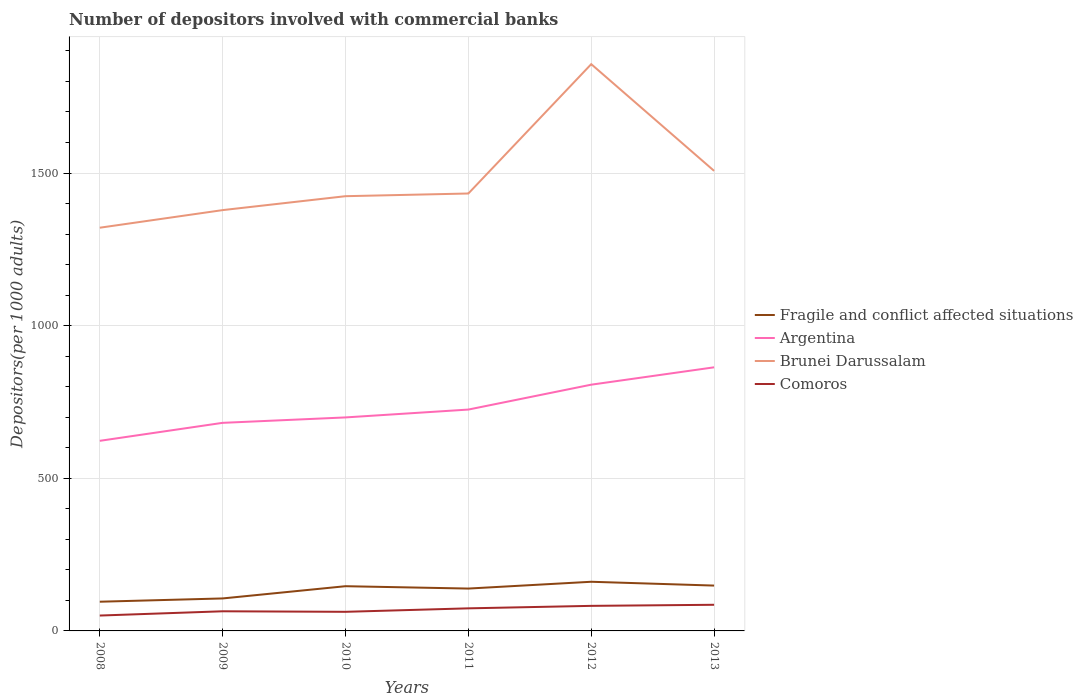Does the line corresponding to Argentina intersect with the line corresponding to Comoros?
Offer a terse response. No. Is the number of lines equal to the number of legend labels?
Your answer should be very brief. Yes. Across all years, what is the maximum number of depositors involved with commercial banks in Brunei Darussalam?
Keep it short and to the point. 1320.81. In which year was the number of depositors involved with commercial banks in Argentina maximum?
Keep it short and to the point. 2008. What is the total number of depositors involved with commercial banks in Brunei Darussalam in the graph?
Make the answer very short. -128.58. What is the difference between the highest and the second highest number of depositors involved with commercial banks in Brunei Darussalam?
Provide a short and direct response. 535.79. Is the number of depositors involved with commercial banks in Fragile and conflict affected situations strictly greater than the number of depositors involved with commercial banks in Brunei Darussalam over the years?
Give a very brief answer. Yes. How many lines are there?
Make the answer very short. 4. Are the values on the major ticks of Y-axis written in scientific E-notation?
Your answer should be very brief. No. Does the graph contain any zero values?
Offer a terse response. No. How are the legend labels stacked?
Provide a short and direct response. Vertical. What is the title of the graph?
Your answer should be compact. Number of depositors involved with commercial banks. Does "Namibia" appear as one of the legend labels in the graph?
Your response must be concise. No. What is the label or title of the Y-axis?
Make the answer very short. Depositors(per 1000 adults). What is the Depositors(per 1000 adults) in Fragile and conflict affected situations in 2008?
Provide a succinct answer. 95.65. What is the Depositors(per 1000 adults) in Argentina in 2008?
Ensure brevity in your answer.  622.73. What is the Depositors(per 1000 adults) in Brunei Darussalam in 2008?
Offer a terse response. 1320.81. What is the Depositors(per 1000 adults) in Comoros in 2008?
Your answer should be compact. 50.36. What is the Depositors(per 1000 adults) in Fragile and conflict affected situations in 2009?
Ensure brevity in your answer.  106.41. What is the Depositors(per 1000 adults) of Argentina in 2009?
Give a very brief answer. 681.62. What is the Depositors(per 1000 adults) in Brunei Darussalam in 2009?
Make the answer very short. 1378.46. What is the Depositors(per 1000 adults) in Comoros in 2009?
Keep it short and to the point. 64.34. What is the Depositors(per 1000 adults) in Fragile and conflict affected situations in 2010?
Offer a very short reply. 146.5. What is the Depositors(per 1000 adults) in Argentina in 2010?
Provide a short and direct response. 699.37. What is the Depositors(per 1000 adults) in Brunei Darussalam in 2010?
Your answer should be very brief. 1424.06. What is the Depositors(per 1000 adults) of Comoros in 2010?
Offer a very short reply. 62.59. What is the Depositors(per 1000 adults) in Fragile and conflict affected situations in 2011?
Provide a short and direct response. 138.74. What is the Depositors(per 1000 adults) of Argentina in 2011?
Make the answer very short. 725.1. What is the Depositors(per 1000 adults) in Brunei Darussalam in 2011?
Your response must be concise. 1432.88. What is the Depositors(per 1000 adults) of Comoros in 2011?
Provide a succinct answer. 73.96. What is the Depositors(per 1000 adults) of Fragile and conflict affected situations in 2012?
Keep it short and to the point. 161.02. What is the Depositors(per 1000 adults) of Argentina in 2012?
Make the answer very short. 806.63. What is the Depositors(per 1000 adults) in Brunei Darussalam in 2012?
Keep it short and to the point. 1856.6. What is the Depositors(per 1000 adults) in Comoros in 2012?
Give a very brief answer. 82.09. What is the Depositors(per 1000 adults) of Fragile and conflict affected situations in 2013?
Ensure brevity in your answer.  148.53. What is the Depositors(per 1000 adults) in Argentina in 2013?
Ensure brevity in your answer.  863.51. What is the Depositors(per 1000 adults) of Brunei Darussalam in 2013?
Provide a short and direct response. 1507.03. What is the Depositors(per 1000 adults) in Comoros in 2013?
Give a very brief answer. 85.63. Across all years, what is the maximum Depositors(per 1000 adults) of Fragile and conflict affected situations?
Your answer should be compact. 161.02. Across all years, what is the maximum Depositors(per 1000 adults) in Argentina?
Ensure brevity in your answer.  863.51. Across all years, what is the maximum Depositors(per 1000 adults) in Brunei Darussalam?
Your answer should be very brief. 1856.6. Across all years, what is the maximum Depositors(per 1000 adults) in Comoros?
Provide a succinct answer. 85.63. Across all years, what is the minimum Depositors(per 1000 adults) in Fragile and conflict affected situations?
Offer a terse response. 95.65. Across all years, what is the minimum Depositors(per 1000 adults) in Argentina?
Keep it short and to the point. 622.73. Across all years, what is the minimum Depositors(per 1000 adults) of Brunei Darussalam?
Offer a terse response. 1320.81. Across all years, what is the minimum Depositors(per 1000 adults) of Comoros?
Keep it short and to the point. 50.36. What is the total Depositors(per 1000 adults) in Fragile and conflict affected situations in the graph?
Make the answer very short. 796.85. What is the total Depositors(per 1000 adults) of Argentina in the graph?
Ensure brevity in your answer.  4398.97. What is the total Depositors(per 1000 adults) in Brunei Darussalam in the graph?
Provide a succinct answer. 8919.83. What is the total Depositors(per 1000 adults) of Comoros in the graph?
Provide a short and direct response. 418.97. What is the difference between the Depositors(per 1000 adults) of Fragile and conflict affected situations in 2008 and that in 2009?
Provide a short and direct response. -10.75. What is the difference between the Depositors(per 1000 adults) of Argentina in 2008 and that in 2009?
Provide a short and direct response. -58.89. What is the difference between the Depositors(per 1000 adults) of Brunei Darussalam in 2008 and that in 2009?
Provide a short and direct response. -57.65. What is the difference between the Depositors(per 1000 adults) of Comoros in 2008 and that in 2009?
Provide a short and direct response. -13.99. What is the difference between the Depositors(per 1000 adults) of Fragile and conflict affected situations in 2008 and that in 2010?
Make the answer very short. -50.84. What is the difference between the Depositors(per 1000 adults) in Argentina in 2008 and that in 2010?
Your answer should be very brief. -76.64. What is the difference between the Depositors(per 1000 adults) in Brunei Darussalam in 2008 and that in 2010?
Keep it short and to the point. -103.26. What is the difference between the Depositors(per 1000 adults) of Comoros in 2008 and that in 2010?
Your response must be concise. -12.23. What is the difference between the Depositors(per 1000 adults) of Fragile and conflict affected situations in 2008 and that in 2011?
Provide a short and direct response. -43.09. What is the difference between the Depositors(per 1000 adults) of Argentina in 2008 and that in 2011?
Offer a very short reply. -102.37. What is the difference between the Depositors(per 1000 adults) of Brunei Darussalam in 2008 and that in 2011?
Your answer should be very brief. -112.07. What is the difference between the Depositors(per 1000 adults) in Comoros in 2008 and that in 2011?
Offer a terse response. -23.61. What is the difference between the Depositors(per 1000 adults) in Fragile and conflict affected situations in 2008 and that in 2012?
Make the answer very short. -65.37. What is the difference between the Depositors(per 1000 adults) in Argentina in 2008 and that in 2012?
Your answer should be very brief. -183.9. What is the difference between the Depositors(per 1000 adults) in Brunei Darussalam in 2008 and that in 2012?
Your answer should be compact. -535.79. What is the difference between the Depositors(per 1000 adults) of Comoros in 2008 and that in 2012?
Keep it short and to the point. -31.74. What is the difference between the Depositors(per 1000 adults) in Fragile and conflict affected situations in 2008 and that in 2013?
Make the answer very short. -52.88. What is the difference between the Depositors(per 1000 adults) of Argentina in 2008 and that in 2013?
Ensure brevity in your answer.  -240.78. What is the difference between the Depositors(per 1000 adults) in Brunei Darussalam in 2008 and that in 2013?
Give a very brief answer. -186.23. What is the difference between the Depositors(per 1000 adults) in Comoros in 2008 and that in 2013?
Offer a very short reply. -35.27. What is the difference between the Depositors(per 1000 adults) of Fragile and conflict affected situations in 2009 and that in 2010?
Offer a very short reply. -40.09. What is the difference between the Depositors(per 1000 adults) in Argentina in 2009 and that in 2010?
Your response must be concise. -17.75. What is the difference between the Depositors(per 1000 adults) of Brunei Darussalam in 2009 and that in 2010?
Offer a terse response. -45.61. What is the difference between the Depositors(per 1000 adults) of Comoros in 2009 and that in 2010?
Make the answer very short. 1.75. What is the difference between the Depositors(per 1000 adults) of Fragile and conflict affected situations in 2009 and that in 2011?
Make the answer very short. -32.34. What is the difference between the Depositors(per 1000 adults) of Argentina in 2009 and that in 2011?
Give a very brief answer. -43.48. What is the difference between the Depositors(per 1000 adults) of Brunei Darussalam in 2009 and that in 2011?
Your answer should be compact. -54.42. What is the difference between the Depositors(per 1000 adults) of Comoros in 2009 and that in 2011?
Your response must be concise. -9.62. What is the difference between the Depositors(per 1000 adults) in Fragile and conflict affected situations in 2009 and that in 2012?
Offer a terse response. -54.61. What is the difference between the Depositors(per 1000 adults) of Argentina in 2009 and that in 2012?
Provide a succinct answer. -125.01. What is the difference between the Depositors(per 1000 adults) in Brunei Darussalam in 2009 and that in 2012?
Your answer should be compact. -478.14. What is the difference between the Depositors(per 1000 adults) of Comoros in 2009 and that in 2012?
Give a very brief answer. -17.75. What is the difference between the Depositors(per 1000 adults) of Fragile and conflict affected situations in 2009 and that in 2013?
Make the answer very short. -42.13. What is the difference between the Depositors(per 1000 adults) in Argentina in 2009 and that in 2013?
Ensure brevity in your answer.  -181.89. What is the difference between the Depositors(per 1000 adults) in Brunei Darussalam in 2009 and that in 2013?
Your answer should be compact. -128.58. What is the difference between the Depositors(per 1000 adults) of Comoros in 2009 and that in 2013?
Ensure brevity in your answer.  -21.29. What is the difference between the Depositors(per 1000 adults) in Fragile and conflict affected situations in 2010 and that in 2011?
Provide a short and direct response. 7.75. What is the difference between the Depositors(per 1000 adults) of Argentina in 2010 and that in 2011?
Provide a succinct answer. -25.73. What is the difference between the Depositors(per 1000 adults) in Brunei Darussalam in 2010 and that in 2011?
Your answer should be compact. -8.82. What is the difference between the Depositors(per 1000 adults) in Comoros in 2010 and that in 2011?
Your answer should be compact. -11.38. What is the difference between the Depositors(per 1000 adults) of Fragile and conflict affected situations in 2010 and that in 2012?
Provide a succinct answer. -14.52. What is the difference between the Depositors(per 1000 adults) in Argentina in 2010 and that in 2012?
Offer a terse response. -107.26. What is the difference between the Depositors(per 1000 adults) in Brunei Darussalam in 2010 and that in 2012?
Provide a succinct answer. -432.53. What is the difference between the Depositors(per 1000 adults) in Comoros in 2010 and that in 2012?
Ensure brevity in your answer.  -19.5. What is the difference between the Depositors(per 1000 adults) in Fragile and conflict affected situations in 2010 and that in 2013?
Keep it short and to the point. -2.04. What is the difference between the Depositors(per 1000 adults) in Argentina in 2010 and that in 2013?
Make the answer very short. -164.14. What is the difference between the Depositors(per 1000 adults) of Brunei Darussalam in 2010 and that in 2013?
Offer a terse response. -82.97. What is the difference between the Depositors(per 1000 adults) in Comoros in 2010 and that in 2013?
Provide a succinct answer. -23.04. What is the difference between the Depositors(per 1000 adults) of Fragile and conflict affected situations in 2011 and that in 2012?
Make the answer very short. -22.28. What is the difference between the Depositors(per 1000 adults) in Argentina in 2011 and that in 2012?
Your answer should be very brief. -81.53. What is the difference between the Depositors(per 1000 adults) in Brunei Darussalam in 2011 and that in 2012?
Your answer should be compact. -423.72. What is the difference between the Depositors(per 1000 adults) of Comoros in 2011 and that in 2012?
Offer a very short reply. -8.13. What is the difference between the Depositors(per 1000 adults) in Fragile and conflict affected situations in 2011 and that in 2013?
Your answer should be very brief. -9.79. What is the difference between the Depositors(per 1000 adults) in Argentina in 2011 and that in 2013?
Provide a short and direct response. -138.41. What is the difference between the Depositors(per 1000 adults) in Brunei Darussalam in 2011 and that in 2013?
Ensure brevity in your answer.  -74.15. What is the difference between the Depositors(per 1000 adults) of Comoros in 2011 and that in 2013?
Ensure brevity in your answer.  -11.66. What is the difference between the Depositors(per 1000 adults) in Fragile and conflict affected situations in 2012 and that in 2013?
Offer a terse response. 12.49. What is the difference between the Depositors(per 1000 adults) in Argentina in 2012 and that in 2013?
Your response must be concise. -56.88. What is the difference between the Depositors(per 1000 adults) of Brunei Darussalam in 2012 and that in 2013?
Offer a terse response. 349.56. What is the difference between the Depositors(per 1000 adults) of Comoros in 2012 and that in 2013?
Keep it short and to the point. -3.54. What is the difference between the Depositors(per 1000 adults) in Fragile and conflict affected situations in 2008 and the Depositors(per 1000 adults) in Argentina in 2009?
Offer a terse response. -585.97. What is the difference between the Depositors(per 1000 adults) of Fragile and conflict affected situations in 2008 and the Depositors(per 1000 adults) of Brunei Darussalam in 2009?
Provide a short and direct response. -1282.8. What is the difference between the Depositors(per 1000 adults) in Fragile and conflict affected situations in 2008 and the Depositors(per 1000 adults) in Comoros in 2009?
Your answer should be very brief. 31.31. What is the difference between the Depositors(per 1000 adults) in Argentina in 2008 and the Depositors(per 1000 adults) in Brunei Darussalam in 2009?
Provide a succinct answer. -755.72. What is the difference between the Depositors(per 1000 adults) of Argentina in 2008 and the Depositors(per 1000 adults) of Comoros in 2009?
Provide a short and direct response. 558.39. What is the difference between the Depositors(per 1000 adults) in Brunei Darussalam in 2008 and the Depositors(per 1000 adults) in Comoros in 2009?
Give a very brief answer. 1256.46. What is the difference between the Depositors(per 1000 adults) in Fragile and conflict affected situations in 2008 and the Depositors(per 1000 adults) in Argentina in 2010?
Your response must be concise. -603.72. What is the difference between the Depositors(per 1000 adults) of Fragile and conflict affected situations in 2008 and the Depositors(per 1000 adults) of Brunei Darussalam in 2010?
Your response must be concise. -1328.41. What is the difference between the Depositors(per 1000 adults) of Fragile and conflict affected situations in 2008 and the Depositors(per 1000 adults) of Comoros in 2010?
Your answer should be compact. 33.06. What is the difference between the Depositors(per 1000 adults) in Argentina in 2008 and the Depositors(per 1000 adults) in Brunei Darussalam in 2010?
Your answer should be compact. -801.33. What is the difference between the Depositors(per 1000 adults) of Argentina in 2008 and the Depositors(per 1000 adults) of Comoros in 2010?
Your answer should be very brief. 560.14. What is the difference between the Depositors(per 1000 adults) of Brunei Darussalam in 2008 and the Depositors(per 1000 adults) of Comoros in 2010?
Make the answer very short. 1258.22. What is the difference between the Depositors(per 1000 adults) in Fragile and conflict affected situations in 2008 and the Depositors(per 1000 adults) in Argentina in 2011?
Make the answer very short. -629.45. What is the difference between the Depositors(per 1000 adults) in Fragile and conflict affected situations in 2008 and the Depositors(per 1000 adults) in Brunei Darussalam in 2011?
Provide a succinct answer. -1337.23. What is the difference between the Depositors(per 1000 adults) in Fragile and conflict affected situations in 2008 and the Depositors(per 1000 adults) in Comoros in 2011?
Ensure brevity in your answer.  21.69. What is the difference between the Depositors(per 1000 adults) of Argentina in 2008 and the Depositors(per 1000 adults) of Brunei Darussalam in 2011?
Offer a terse response. -810.15. What is the difference between the Depositors(per 1000 adults) in Argentina in 2008 and the Depositors(per 1000 adults) in Comoros in 2011?
Provide a short and direct response. 548.77. What is the difference between the Depositors(per 1000 adults) of Brunei Darussalam in 2008 and the Depositors(per 1000 adults) of Comoros in 2011?
Give a very brief answer. 1246.84. What is the difference between the Depositors(per 1000 adults) of Fragile and conflict affected situations in 2008 and the Depositors(per 1000 adults) of Argentina in 2012?
Make the answer very short. -710.98. What is the difference between the Depositors(per 1000 adults) of Fragile and conflict affected situations in 2008 and the Depositors(per 1000 adults) of Brunei Darussalam in 2012?
Your answer should be very brief. -1760.94. What is the difference between the Depositors(per 1000 adults) in Fragile and conflict affected situations in 2008 and the Depositors(per 1000 adults) in Comoros in 2012?
Offer a very short reply. 13.56. What is the difference between the Depositors(per 1000 adults) of Argentina in 2008 and the Depositors(per 1000 adults) of Brunei Darussalam in 2012?
Your answer should be compact. -1233.86. What is the difference between the Depositors(per 1000 adults) in Argentina in 2008 and the Depositors(per 1000 adults) in Comoros in 2012?
Ensure brevity in your answer.  540.64. What is the difference between the Depositors(per 1000 adults) in Brunei Darussalam in 2008 and the Depositors(per 1000 adults) in Comoros in 2012?
Give a very brief answer. 1238.71. What is the difference between the Depositors(per 1000 adults) of Fragile and conflict affected situations in 2008 and the Depositors(per 1000 adults) of Argentina in 2013?
Your answer should be very brief. -767.86. What is the difference between the Depositors(per 1000 adults) in Fragile and conflict affected situations in 2008 and the Depositors(per 1000 adults) in Brunei Darussalam in 2013?
Provide a short and direct response. -1411.38. What is the difference between the Depositors(per 1000 adults) in Fragile and conflict affected situations in 2008 and the Depositors(per 1000 adults) in Comoros in 2013?
Offer a very short reply. 10.02. What is the difference between the Depositors(per 1000 adults) of Argentina in 2008 and the Depositors(per 1000 adults) of Brunei Darussalam in 2013?
Give a very brief answer. -884.3. What is the difference between the Depositors(per 1000 adults) in Argentina in 2008 and the Depositors(per 1000 adults) in Comoros in 2013?
Provide a short and direct response. 537.1. What is the difference between the Depositors(per 1000 adults) of Brunei Darussalam in 2008 and the Depositors(per 1000 adults) of Comoros in 2013?
Offer a very short reply. 1235.18. What is the difference between the Depositors(per 1000 adults) in Fragile and conflict affected situations in 2009 and the Depositors(per 1000 adults) in Argentina in 2010?
Your answer should be very brief. -592.96. What is the difference between the Depositors(per 1000 adults) of Fragile and conflict affected situations in 2009 and the Depositors(per 1000 adults) of Brunei Darussalam in 2010?
Give a very brief answer. -1317.66. What is the difference between the Depositors(per 1000 adults) in Fragile and conflict affected situations in 2009 and the Depositors(per 1000 adults) in Comoros in 2010?
Provide a succinct answer. 43.82. What is the difference between the Depositors(per 1000 adults) of Argentina in 2009 and the Depositors(per 1000 adults) of Brunei Darussalam in 2010?
Offer a terse response. -742.44. What is the difference between the Depositors(per 1000 adults) in Argentina in 2009 and the Depositors(per 1000 adults) in Comoros in 2010?
Provide a short and direct response. 619.03. What is the difference between the Depositors(per 1000 adults) of Brunei Darussalam in 2009 and the Depositors(per 1000 adults) of Comoros in 2010?
Give a very brief answer. 1315.87. What is the difference between the Depositors(per 1000 adults) of Fragile and conflict affected situations in 2009 and the Depositors(per 1000 adults) of Argentina in 2011?
Ensure brevity in your answer.  -618.7. What is the difference between the Depositors(per 1000 adults) in Fragile and conflict affected situations in 2009 and the Depositors(per 1000 adults) in Brunei Darussalam in 2011?
Keep it short and to the point. -1326.47. What is the difference between the Depositors(per 1000 adults) of Fragile and conflict affected situations in 2009 and the Depositors(per 1000 adults) of Comoros in 2011?
Your response must be concise. 32.44. What is the difference between the Depositors(per 1000 adults) in Argentina in 2009 and the Depositors(per 1000 adults) in Brunei Darussalam in 2011?
Give a very brief answer. -751.26. What is the difference between the Depositors(per 1000 adults) in Argentina in 2009 and the Depositors(per 1000 adults) in Comoros in 2011?
Keep it short and to the point. 607.65. What is the difference between the Depositors(per 1000 adults) in Brunei Darussalam in 2009 and the Depositors(per 1000 adults) in Comoros in 2011?
Your answer should be very brief. 1304.49. What is the difference between the Depositors(per 1000 adults) in Fragile and conflict affected situations in 2009 and the Depositors(per 1000 adults) in Argentina in 2012?
Provide a short and direct response. -700.23. What is the difference between the Depositors(per 1000 adults) of Fragile and conflict affected situations in 2009 and the Depositors(per 1000 adults) of Brunei Darussalam in 2012?
Offer a very short reply. -1750.19. What is the difference between the Depositors(per 1000 adults) of Fragile and conflict affected situations in 2009 and the Depositors(per 1000 adults) of Comoros in 2012?
Offer a very short reply. 24.32. What is the difference between the Depositors(per 1000 adults) in Argentina in 2009 and the Depositors(per 1000 adults) in Brunei Darussalam in 2012?
Offer a terse response. -1174.98. What is the difference between the Depositors(per 1000 adults) in Argentina in 2009 and the Depositors(per 1000 adults) in Comoros in 2012?
Your answer should be compact. 599.53. What is the difference between the Depositors(per 1000 adults) in Brunei Darussalam in 2009 and the Depositors(per 1000 adults) in Comoros in 2012?
Ensure brevity in your answer.  1296.36. What is the difference between the Depositors(per 1000 adults) of Fragile and conflict affected situations in 2009 and the Depositors(per 1000 adults) of Argentina in 2013?
Offer a terse response. -757.1. What is the difference between the Depositors(per 1000 adults) of Fragile and conflict affected situations in 2009 and the Depositors(per 1000 adults) of Brunei Darussalam in 2013?
Your answer should be very brief. -1400.63. What is the difference between the Depositors(per 1000 adults) of Fragile and conflict affected situations in 2009 and the Depositors(per 1000 adults) of Comoros in 2013?
Your answer should be very brief. 20.78. What is the difference between the Depositors(per 1000 adults) in Argentina in 2009 and the Depositors(per 1000 adults) in Brunei Darussalam in 2013?
Ensure brevity in your answer.  -825.41. What is the difference between the Depositors(per 1000 adults) in Argentina in 2009 and the Depositors(per 1000 adults) in Comoros in 2013?
Your answer should be compact. 595.99. What is the difference between the Depositors(per 1000 adults) in Brunei Darussalam in 2009 and the Depositors(per 1000 adults) in Comoros in 2013?
Offer a very short reply. 1292.83. What is the difference between the Depositors(per 1000 adults) of Fragile and conflict affected situations in 2010 and the Depositors(per 1000 adults) of Argentina in 2011?
Offer a terse response. -578.61. What is the difference between the Depositors(per 1000 adults) in Fragile and conflict affected situations in 2010 and the Depositors(per 1000 adults) in Brunei Darussalam in 2011?
Your answer should be compact. -1286.38. What is the difference between the Depositors(per 1000 adults) of Fragile and conflict affected situations in 2010 and the Depositors(per 1000 adults) of Comoros in 2011?
Provide a short and direct response. 72.53. What is the difference between the Depositors(per 1000 adults) of Argentina in 2010 and the Depositors(per 1000 adults) of Brunei Darussalam in 2011?
Your answer should be compact. -733.51. What is the difference between the Depositors(per 1000 adults) of Argentina in 2010 and the Depositors(per 1000 adults) of Comoros in 2011?
Your answer should be very brief. 625.41. What is the difference between the Depositors(per 1000 adults) in Brunei Darussalam in 2010 and the Depositors(per 1000 adults) in Comoros in 2011?
Make the answer very short. 1350.1. What is the difference between the Depositors(per 1000 adults) in Fragile and conflict affected situations in 2010 and the Depositors(per 1000 adults) in Argentina in 2012?
Ensure brevity in your answer.  -660.14. What is the difference between the Depositors(per 1000 adults) in Fragile and conflict affected situations in 2010 and the Depositors(per 1000 adults) in Brunei Darussalam in 2012?
Provide a short and direct response. -1710.1. What is the difference between the Depositors(per 1000 adults) in Fragile and conflict affected situations in 2010 and the Depositors(per 1000 adults) in Comoros in 2012?
Your answer should be compact. 64.4. What is the difference between the Depositors(per 1000 adults) of Argentina in 2010 and the Depositors(per 1000 adults) of Brunei Darussalam in 2012?
Ensure brevity in your answer.  -1157.23. What is the difference between the Depositors(per 1000 adults) of Argentina in 2010 and the Depositors(per 1000 adults) of Comoros in 2012?
Your answer should be very brief. 617.28. What is the difference between the Depositors(per 1000 adults) of Brunei Darussalam in 2010 and the Depositors(per 1000 adults) of Comoros in 2012?
Your answer should be compact. 1341.97. What is the difference between the Depositors(per 1000 adults) in Fragile and conflict affected situations in 2010 and the Depositors(per 1000 adults) in Argentina in 2013?
Your answer should be very brief. -717.01. What is the difference between the Depositors(per 1000 adults) of Fragile and conflict affected situations in 2010 and the Depositors(per 1000 adults) of Brunei Darussalam in 2013?
Give a very brief answer. -1360.54. What is the difference between the Depositors(per 1000 adults) of Fragile and conflict affected situations in 2010 and the Depositors(per 1000 adults) of Comoros in 2013?
Provide a succinct answer. 60.87. What is the difference between the Depositors(per 1000 adults) in Argentina in 2010 and the Depositors(per 1000 adults) in Brunei Darussalam in 2013?
Offer a terse response. -807.66. What is the difference between the Depositors(per 1000 adults) in Argentina in 2010 and the Depositors(per 1000 adults) in Comoros in 2013?
Keep it short and to the point. 613.74. What is the difference between the Depositors(per 1000 adults) of Brunei Darussalam in 2010 and the Depositors(per 1000 adults) of Comoros in 2013?
Your answer should be compact. 1338.43. What is the difference between the Depositors(per 1000 adults) in Fragile and conflict affected situations in 2011 and the Depositors(per 1000 adults) in Argentina in 2012?
Give a very brief answer. -667.89. What is the difference between the Depositors(per 1000 adults) in Fragile and conflict affected situations in 2011 and the Depositors(per 1000 adults) in Brunei Darussalam in 2012?
Ensure brevity in your answer.  -1717.85. What is the difference between the Depositors(per 1000 adults) of Fragile and conflict affected situations in 2011 and the Depositors(per 1000 adults) of Comoros in 2012?
Offer a very short reply. 56.65. What is the difference between the Depositors(per 1000 adults) in Argentina in 2011 and the Depositors(per 1000 adults) in Brunei Darussalam in 2012?
Provide a succinct answer. -1131.49. What is the difference between the Depositors(per 1000 adults) in Argentina in 2011 and the Depositors(per 1000 adults) in Comoros in 2012?
Offer a very short reply. 643.01. What is the difference between the Depositors(per 1000 adults) of Brunei Darussalam in 2011 and the Depositors(per 1000 adults) of Comoros in 2012?
Ensure brevity in your answer.  1350.79. What is the difference between the Depositors(per 1000 adults) in Fragile and conflict affected situations in 2011 and the Depositors(per 1000 adults) in Argentina in 2013?
Provide a short and direct response. -724.77. What is the difference between the Depositors(per 1000 adults) of Fragile and conflict affected situations in 2011 and the Depositors(per 1000 adults) of Brunei Darussalam in 2013?
Ensure brevity in your answer.  -1368.29. What is the difference between the Depositors(per 1000 adults) in Fragile and conflict affected situations in 2011 and the Depositors(per 1000 adults) in Comoros in 2013?
Offer a terse response. 53.11. What is the difference between the Depositors(per 1000 adults) of Argentina in 2011 and the Depositors(per 1000 adults) of Brunei Darussalam in 2013?
Your answer should be very brief. -781.93. What is the difference between the Depositors(per 1000 adults) of Argentina in 2011 and the Depositors(per 1000 adults) of Comoros in 2013?
Give a very brief answer. 639.47. What is the difference between the Depositors(per 1000 adults) of Brunei Darussalam in 2011 and the Depositors(per 1000 adults) of Comoros in 2013?
Provide a succinct answer. 1347.25. What is the difference between the Depositors(per 1000 adults) of Fragile and conflict affected situations in 2012 and the Depositors(per 1000 adults) of Argentina in 2013?
Make the answer very short. -702.49. What is the difference between the Depositors(per 1000 adults) in Fragile and conflict affected situations in 2012 and the Depositors(per 1000 adults) in Brunei Darussalam in 2013?
Offer a very short reply. -1346.01. What is the difference between the Depositors(per 1000 adults) in Fragile and conflict affected situations in 2012 and the Depositors(per 1000 adults) in Comoros in 2013?
Your answer should be compact. 75.39. What is the difference between the Depositors(per 1000 adults) of Argentina in 2012 and the Depositors(per 1000 adults) of Brunei Darussalam in 2013?
Your answer should be very brief. -700.4. What is the difference between the Depositors(per 1000 adults) in Argentina in 2012 and the Depositors(per 1000 adults) in Comoros in 2013?
Your response must be concise. 721. What is the difference between the Depositors(per 1000 adults) in Brunei Darussalam in 2012 and the Depositors(per 1000 adults) in Comoros in 2013?
Offer a very short reply. 1770.97. What is the average Depositors(per 1000 adults) of Fragile and conflict affected situations per year?
Your answer should be very brief. 132.81. What is the average Depositors(per 1000 adults) of Argentina per year?
Offer a very short reply. 733.16. What is the average Depositors(per 1000 adults) of Brunei Darussalam per year?
Give a very brief answer. 1486.64. What is the average Depositors(per 1000 adults) in Comoros per year?
Your response must be concise. 69.83. In the year 2008, what is the difference between the Depositors(per 1000 adults) in Fragile and conflict affected situations and Depositors(per 1000 adults) in Argentina?
Provide a short and direct response. -527.08. In the year 2008, what is the difference between the Depositors(per 1000 adults) of Fragile and conflict affected situations and Depositors(per 1000 adults) of Brunei Darussalam?
Your answer should be compact. -1225.15. In the year 2008, what is the difference between the Depositors(per 1000 adults) of Fragile and conflict affected situations and Depositors(per 1000 adults) of Comoros?
Make the answer very short. 45.3. In the year 2008, what is the difference between the Depositors(per 1000 adults) of Argentina and Depositors(per 1000 adults) of Brunei Darussalam?
Your answer should be compact. -698.07. In the year 2008, what is the difference between the Depositors(per 1000 adults) in Argentina and Depositors(per 1000 adults) in Comoros?
Your answer should be very brief. 572.38. In the year 2008, what is the difference between the Depositors(per 1000 adults) of Brunei Darussalam and Depositors(per 1000 adults) of Comoros?
Keep it short and to the point. 1270.45. In the year 2009, what is the difference between the Depositors(per 1000 adults) of Fragile and conflict affected situations and Depositors(per 1000 adults) of Argentina?
Your answer should be very brief. -575.21. In the year 2009, what is the difference between the Depositors(per 1000 adults) in Fragile and conflict affected situations and Depositors(per 1000 adults) in Brunei Darussalam?
Keep it short and to the point. -1272.05. In the year 2009, what is the difference between the Depositors(per 1000 adults) of Fragile and conflict affected situations and Depositors(per 1000 adults) of Comoros?
Your response must be concise. 42.06. In the year 2009, what is the difference between the Depositors(per 1000 adults) in Argentina and Depositors(per 1000 adults) in Brunei Darussalam?
Provide a short and direct response. -696.84. In the year 2009, what is the difference between the Depositors(per 1000 adults) in Argentina and Depositors(per 1000 adults) in Comoros?
Your response must be concise. 617.28. In the year 2009, what is the difference between the Depositors(per 1000 adults) of Brunei Darussalam and Depositors(per 1000 adults) of Comoros?
Ensure brevity in your answer.  1314.11. In the year 2010, what is the difference between the Depositors(per 1000 adults) of Fragile and conflict affected situations and Depositors(per 1000 adults) of Argentina?
Ensure brevity in your answer.  -552.87. In the year 2010, what is the difference between the Depositors(per 1000 adults) in Fragile and conflict affected situations and Depositors(per 1000 adults) in Brunei Darussalam?
Your answer should be compact. -1277.57. In the year 2010, what is the difference between the Depositors(per 1000 adults) of Fragile and conflict affected situations and Depositors(per 1000 adults) of Comoros?
Make the answer very short. 83.91. In the year 2010, what is the difference between the Depositors(per 1000 adults) in Argentina and Depositors(per 1000 adults) in Brunei Darussalam?
Provide a short and direct response. -724.69. In the year 2010, what is the difference between the Depositors(per 1000 adults) in Argentina and Depositors(per 1000 adults) in Comoros?
Offer a terse response. 636.78. In the year 2010, what is the difference between the Depositors(per 1000 adults) of Brunei Darussalam and Depositors(per 1000 adults) of Comoros?
Your answer should be compact. 1361.47. In the year 2011, what is the difference between the Depositors(per 1000 adults) in Fragile and conflict affected situations and Depositors(per 1000 adults) in Argentina?
Ensure brevity in your answer.  -586.36. In the year 2011, what is the difference between the Depositors(per 1000 adults) of Fragile and conflict affected situations and Depositors(per 1000 adults) of Brunei Darussalam?
Provide a succinct answer. -1294.13. In the year 2011, what is the difference between the Depositors(per 1000 adults) in Fragile and conflict affected situations and Depositors(per 1000 adults) in Comoros?
Keep it short and to the point. 64.78. In the year 2011, what is the difference between the Depositors(per 1000 adults) of Argentina and Depositors(per 1000 adults) of Brunei Darussalam?
Make the answer very short. -707.78. In the year 2011, what is the difference between the Depositors(per 1000 adults) of Argentina and Depositors(per 1000 adults) of Comoros?
Provide a succinct answer. 651.14. In the year 2011, what is the difference between the Depositors(per 1000 adults) of Brunei Darussalam and Depositors(per 1000 adults) of Comoros?
Make the answer very short. 1358.91. In the year 2012, what is the difference between the Depositors(per 1000 adults) in Fragile and conflict affected situations and Depositors(per 1000 adults) in Argentina?
Ensure brevity in your answer.  -645.61. In the year 2012, what is the difference between the Depositors(per 1000 adults) in Fragile and conflict affected situations and Depositors(per 1000 adults) in Brunei Darussalam?
Provide a succinct answer. -1695.58. In the year 2012, what is the difference between the Depositors(per 1000 adults) in Fragile and conflict affected situations and Depositors(per 1000 adults) in Comoros?
Make the answer very short. 78.93. In the year 2012, what is the difference between the Depositors(per 1000 adults) of Argentina and Depositors(per 1000 adults) of Brunei Darussalam?
Offer a terse response. -1049.96. In the year 2012, what is the difference between the Depositors(per 1000 adults) of Argentina and Depositors(per 1000 adults) of Comoros?
Provide a succinct answer. 724.54. In the year 2012, what is the difference between the Depositors(per 1000 adults) in Brunei Darussalam and Depositors(per 1000 adults) in Comoros?
Offer a terse response. 1774.5. In the year 2013, what is the difference between the Depositors(per 1000 adults) of Fragile and conflict affected situations and Depositors(per 1000 adults) of Argentina?
Your answer should be compact. -714.98. In the year 2013, what is the difference between the Depositors(per 1000 adults) of Fragile and conflict affected situations and Depositors(per 1000 adults) of Brunei Darussalam?
Ensure brevity in your answer.  -1358.5. In the year 2013, what is the difference between the Depositors(per 1000 adults) of Fragile and conflict affected situations and Depositors(per 1000 adults) of Comoros?
Offer a very short reply. 62.9. In the year 2013, what is the difference between the Depositors(per 1000 adults) in Argentina and Depositors(per 1000 adults) in Brunei Darussalam?
Offer a terse response. -643.52. In the year 2013, what is the difference between the Depositors(per 1000 adults) of Argentina and Depositors(per 1000 adults) of Comoros?
Your answer should be very brief. 777.88. In the year 2013, what is the difference between the Depositors(per 1000 adults) of Brunei Darussalam and Depositors(per 1000 adults) of Comoros?
Provide a short and direct response. 1421.4. What is the ratio of the Depositors(per 1000 adults) in Fragile and conflict affected situations in 2008 to that in 2009?
Make the answer very short. 0.9. What is the ratio of the Depositors(per 1000 adults) in Argentina in 2008 to that in 2009?
Your response must be concise. 0.91. What is the ratio of the Depositors(per 1000 adults) in Brunei Darussalam in 2008 to that in 2009?
Offer a very short reply. 0.96. What is the ratio of the Depositors(per 1000 adults) in Comoros in 2008 to that in 2009?
Keep it short and to the point. 0.78. What is the ratio of the Depositors(per 1000 adults) in Fragile and conflict affected situations in 2008 to that in 2010?
Provide a short and direct response. 0.65. What is the ratio of the Depositors(per 1000 adults) in Argentina in 2008 to that in 2010?
Provide a succinct answer. 0.89. What is the ratio of the Depositors(per 1000 adults) in Brunei Darussalam in 2008 to that in 2010?
Give a very brief answer. 0.93. What is the ratio of the Depositors(per 1000 adults) of Comoros in 2008 to that in 2010?
Offer a terse response. 0.8. What is the ratio of the Depositors(per 1000 adults) of Fragile and conflict affected situations in 2008 to that in 2011?
Offer a very short reply. 0.69. What is the ratio of the Depositors(per 1000 adults) in Argentina in 2008 to that in 2011?
Give a very brief answer. 0.86. What is the ratio of the Depositors(per 1000 adults) of Brunei Darussalam in 2008 to that in 2011?
Give a very brief answer. 0.92. What is the ratio of the Depositors(per 1000 adults) in Comoros in 2008 to that in 2011?
Offer a very short reply. 0.68. What is the ratio of the Depositors(per 1000 adults) in Fragile and conflict affected situations in 2008 to that in 2012?
Your answer should be compact. 0.59. What is the ratio of the Depositors(per 1000 adults) in Argentina in 2008 to that in 2012?
Make the answer very short. 0.77. What is the ratio of the Depositors(per 1000 adults) of Brunei Darussalam in 2008 to that in 2012?
Provide a short and direct response. 0.71. What is the ratio of the Depositors(per 1000 adults) of Comoros in 2008 to that in 2012?
Offer a terse response. 0.61. What is the ratio of the Depositors(per 1000 adults) of Fragile and conflict affected situations in 2008 to that in 2013?
Keep it short and to the point. 0.64. What is the ratio of the Depositors(per 1000 adults) of Argentina in 2008 to that in 2013?
Ensure brevity in your answer.  0.72. What is the ratio of the Depositors(per 1000 adults) of Brunei Darussalam in 2008 to that in 2013?
Offer a terse response. 0.88. What is the ratio of the Depositors(per 1000 adults) of Comoros in 2008 to that in 2013?
Ensure brevity in your answer.  0.59. What is the ratio of the Depositors(per 1000 adults) in Fragile and conflict affected situations in 2009 to that in 2010?
Your response must be concise. 0.73. What is the ratio of the Depositors(per 1000 adults) in Argentina in 2009 to that in 2010?
Offer a very short reply. 0.97. What is the ratio of the Depositors(per 1000 adults) of Brunei Darussalam in 2009 to that in 2010?
Provide a short and direct response. 0.97. What is the ratio of the Depositors(per 1000 adults) of Comoros in 2009 to that in 2010?
Ensure brevity in your answer.  1.03. What is the ratio of the Depositors(per 1000 adults) in Fragile and conflict affected situations in 2009 to that in 2011?
Offer a very short reply. 0.77. What is the ratio of the Depositors(per 1000 adults) of Argentina in 2009 to that in 2011?
Offer a terse response. 0.94. What is the ratio of the Depositors(per 1000 adults) in Comoros in 2009 to that in 2011?
Give a very brief answer. 0.87. What is the ratio of the Depositors(per 1000 adults) in Fragile and conflict affected situations in 2009 to that in 2012?
Your answer should be very brief. 0.66. What is the ratio of the Depositors(per 1000 adults) in Argentina in 2009 to that in 2012?
Offer a terse response. 0.84. What is the ratio of the Depositors(per 1000 adults) of Brunei Darussalam in 2009 to that in 2012?
Your answer should be very brief. 0.74. What is the ratio of the Depositors(per 1000 adults) of Comoros in 2009 to that in 2012?
Give a very brief answer. 0.78. What is the ratio of the Depositors(per 1000 adults) of Fragile and conflict affected situations in 2009 to that in 2013?
Offer a very short reply. 0.72. What is the ratio of the Depositors(per 1000 adults) of Argentina in 2009 to that in 2013?
Your answer should be very brief. 0.79. What is the ratio of the Depositors(per 1000 adults) in Brunei Darussalam in 2009 to that in 2013?
Offer a terse response. 0.91. What is the ratio of the Depositors(per 1000 adults) in Comoros in 2009 to that in 2013?
Provide a succinct answer. 0.75. What is the ratio of the Depositors(per 1000 adults) of Fragile and conflict affected situations in 2010 to that in 2011?
Provide a succinct answer. 1.06. What is the ratio of the Depositors(per 1000 adults) in Argentina in 2010 to that in 2011?
Give a very brief answer. 0.96. What is the ratio of the Depositors(per 1000 adults) of Brunei Darussalam in 2010 to that in 2011?
Make the answer very short. 0.99. What is the ratio of the Depositors(per 1000 adults) in Comoros in 2010 to that in 2011?
Keep it short and to the point. 0.85. What is the ratio of the Depositors(per 1000 adults) of Fragile and conflict affected situations in 2010 to that in 2012?
Give a very brief answer. 0.91. What is the ratio of the Depositors(per 1000 adults) in Argentina in 2010 to that in 2012?
Ensure brevity in your answer.  0.87. What is the ratio of the Depositors(per 1000 adults) in Brunei Darussalam in 2010 to that in 2012?
Provide a short and direct response. 0.77. What is the ratio of the Depositors(per 1000 adults) in Comoros in 2010 to that in 2012?
Offer a terse response. 0.76. What is the ratio of the Depositors(per 1000 adults) in Fragile and conflict affected situations in 2010 to that in 2013?
Your answer should be compact. 0.99. What is the ratio of the Depositors(per 1000 adults) in Argentina in 2010 to that in 2013?
Offer a very short reply. 0.81. What is the ratio of the Depositors(per 1000 adults) of Brunei Darussalam in 2010 to that in 2013?
Provide a succinct answer. 0.94. What is the ratio of the Depositors(per 1000 adults) in Comoros in 2010 to that in 2013?
Provide a short and direct response. 0.73. What is the ratio of the Depositors(per 1000 adults) of Fragile and conflict affected situations in 2011 to that in 2012?
Offer a terse response. 0.86. What is the ratio of the Depositors(per 1000 adults) of Argentina in 2011 to that in 2012?
Provide a short and direct response. 0.9. What is the ratio of the Depositors(per 1000 adults) in Brunei Darussalam in 2011 to that in 2012?
Give a very brief answer. 0.77. What is the ratio of the Depositors(per 1000 adults) in Comoros in 2011 to that in 2012?
Offer a terse response. 0.9. What is the ratio of the Depositors(per 1000 adults) in Fragile and conflict affected situations in 2011 to that in 2013?
Ensure brevity in your answer.  0.93. What is the ratio of the Depositors(per 1000 adults) of Argentina in 2011 to that in 2013?
Offer a terse response. 0.84. What is the ratio of the Depositors(per 1000 adults) in Brunei Darussalam in 2011 to that in 2013?
Your answer should be very brief. 0.95. What is the ratio of the Depositors(per 1000 adults) in Comoros in 2011 to that in 2013?
Provide a succinct answer. 0.86. What is the ratio of the Depositors(per 1000 adults) in Fragile and conflict affected situations in 2012 to that in 2013?
Offer a very short reply. 1.08. What is the ratio of the Depositors(per 1000 adults) of Argentina in 2012 to that in 2013?
Make the answer very short. 0.93. What is the ratio of the Depositors(per 1000 adults) of Brunei Darussalam in 2012 to that in 2013?
Provide a short and direct response. 1.23. What is the ratio of the Depositors(per 1000 adults) of Comoros in 2012 to that in 2013?
Your response must be concise. 0.96. What is the difference between the highest and the second highest Depositors(per 1000 adults) of Fragile and conflict affected situations?
Offer a terse response. 12.49. What is the difference between the highest and the second highest Depositors(per 1000 adults) of Argentina?
Offer a very short reply. 56.88. What is the difference between the highest and the second highest Depositors(per 1000 adults) in Brunei Darussalam?
Offer a very short reply. 349.56. What is the difference between the highest and the second highest Depositors(per 1000 adults) of Comoros?
Your answer should be compact. 3.54. What is the difference between the highest and the lowest Depositors(per 1000 adults) in Fragile and conflict affected situations?
Your answer should be very brief. 65.37. What is the difference between the highest and the lowest Depositors(per 1000 adults) in Argentina?
Give a very brief answer. 240.78. What is the difference between the highest and the lowest Depositors(per 1000 adults) in Brunei Darussalam?
Give a very brief answer. 535.79. What is the difference between the highest and the lowest Depositors(per 1000 adults) of Comoros?
Keep it short and to the point. 35.27. 